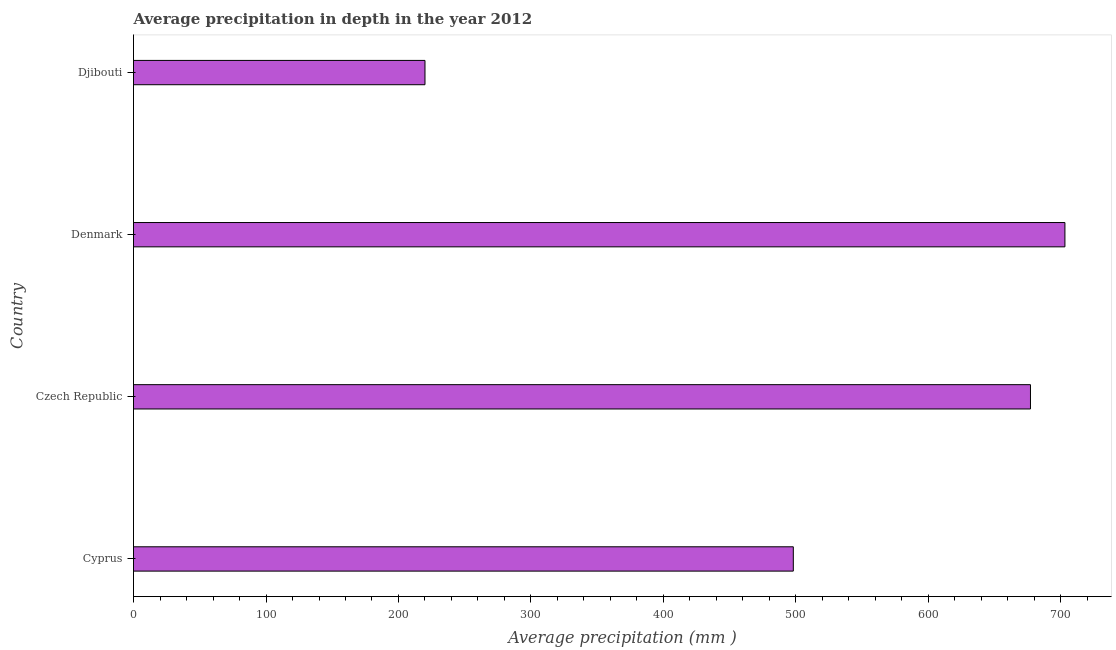What is the title of the graph?
Provide a short and direct response. Average precipitation in depth in the year 2012. What is the label or title of the X-axis?
Offer a terse response. Average precipitation (mm ). What is the label or title of the Y-axis?
Provide a succinct answer. Country. What is the average precipitation in depth in Denmark?
Give a very brief answer. 703. Across all countries, what is the maximum average precipitation in depth?
Provide a short and direct response. 703. Across all countries, what is the minimum average precipitation in depth?
Offer a terse response. 220. In which country was the average precipitation in depth maximum?
Your answer should be very brief. Denmark. In which country was the average precipitation in depth minimum?
Provide a succinct answer. Djibouti. What is the sum of the average precipitation in depth?
Provide a succinct answer. 2098. What is the difference between the average precipitation in depth in Cyprus and Czech Republic?
Provide a succinct answer. -179. What is the average average precipitation in depth per country?
Ensure brevity in your answer.  524. What is the median average precipitation in depth?
Offer a very short reply. 587.5. In how many countries, is the average precipitation in depth greater than 260 mm?
Your answer should be compact. 3. What is the ratio of the average precipitation in depth in Cyprus to that in Czech Republic?
Offer a terse response. 0.74. Is the difference between the average precipitation in depth in Cyprus and Djibouti greater than the difference between any two countries?
Provide a succinct answer. No. What is the difference between the highest and the lowest average precipitation in depth?
Your answer should be compact. 483. What is the difference between two consecutive major ticks on the X-axis?
Your response must be concise. 100. What is the Average precipitation (mm ) of Cyprus?
Your answer should be compact. 498. What is the Average precipitation (mm ) of Czech Republic?
Offer a very short reply. 677. What is the Average precipitation (mm ) of Denmark?
Your response must be concise. 703. What is the Average precipitation (mm ) in Djibouti?
Your answer should be compact. 220. What is the difference between the Average precipitation (mm ) in Cyprus and Czech Republic?
Your response must be concise. -179. What is the difference between the Average precipitation (mm ) in Cyprus and Denmark?
Ensure brevity in your answer.  -205. What is the difference between the Average precipitation (mm ) in Cyprus and Djibouti?
Give a very brief answer. 278. What is the difference between the Average precipitation (mm ) in Czech Republic and Denmark?
Offer a terse response. -26. What is the difference between the Average precipitation (mm ) in Czech Republic and Djibouti?
Offer a very short reply. 457. What is the difference between the Average precipitation (mm ) in Denmark and Djibouti?
Provide a succinct answer. 483. What is the ratio of the Average precipitation (mm ) in Cyprus to that in Czech Republic?
Your answer should be compact. 0.74. What is the ratio of the Average precipitation (mm ) in Cyprus to that in Denmark?
Keep it short and to the point. 0.71. What is the ratio of the Average precipitation (mm ) in Cyprus to that in Djibouti?
Offer a terse response. 2.26. What is the ratio of the Average precipitation (mm ) in Czech Republic to that in Djibouti?
Provide a succinct answer. 3.08. What is the ratio of the Average precipitation (mm ) in Denmark to that in Djibouti?
Offer a very short reply. 3.19. 